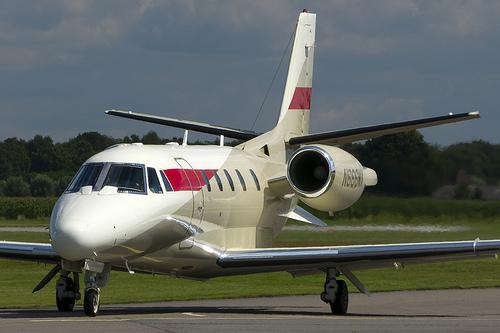Evaluate the visual quality of the image based on the provided information. The image appears to be detailed and clear, with a multitude of object elements such as clouds, grass, and various parts of the airplane being explicitly mentioned. How many total white clouds in blue sky are visible within this image? There are 9 white clouds in the blue sky. Determine the most complex reasoning task that involves both the airplane and its surroundings. Inferring the potential destination or origin of the plane based on its appearance, surroundings, and other visible objects such as signage, logos, or airport facilities. Provide a description of the airplane's tail, including its color and any additional features. The airplane's tail is red and white with a red stripe on its side and a distinct shape at the outer end. Count how many engine, landing gear (wheels), and passenger windows are there on the main airplane. There is one engine, three landing gear wheels, and two sets of passenger windows on the airplane. Craft a brief caption describing the main focus of the image. Red and white plane taking off from airport runway with clouds in blue sky overhead. Identify the main colors seen on the airplane in the picture. The plane is white, red, and tan in color. What sentiment could be conveyed through the image due to the sky's appearance? The sky's dark and gloomy appearance might evoke a sense of gloom or melancholy. Assuming this is a passenger airplane, describe its exterior features which make it suitable for carrying passengers. The exterior of the passenger airplane showcases various passenger windows, a distinct door, and the presence of one or more engines which all contribute to the airplane's ability to transport passengers. Analyze the interaction between the plane and its environment. What is it doing? The airplane is taking off from an airport runway, casting a shadow and interacting with its front and back landing gear wheels. Provide the dimensions and position of the passenger windows on the plane. X:197, Y:166, Width:66, Height:66 What interactions can be observed between the objects in this image? The plane interacts with the runway, the landing gear with the ground, and plane with its shadow. Identify the position and size of the red stripe on the tail of the plane. X:285, Y:83, Width:27, Height:27 What element of the image indicates the time of day? The position of the sun and shadows determine the time of day. Describe the shape of the plane engine. Round and dark. Identify the dimensions and position of the windows for the cockpit crew. X:70, Y:158, Width:94, Height:94 Is the general image quality high or low? The image quality is high. In terms of sentiment, how does this image make you feel? The image feels neutral, with normal everyday activity. How does the sky appear in this image? The sky appears blue with white clouds. Are there any visible numbers or letters in the image? Yes, numbers on the plane and a letter on the plane's engine. How many clouds are there in the sky? 9 white clouds are present in the blue sky. Determine if there are bushes in the image and provide their characteristics if present. Yes, there are dark green bushes present. How many wheels can be seen as part of the landing gear? Three wheels are visible - one front and two back. Identify any anomalies in this image. No significant anomalies detected in the image. Which choice below describes the location of the green grass next to the runway? A) X:245 Y:284 Width:45 Height:45 B) X:174 Y:155 Width:30 Height:30 A) X:245 Y:284 Width:45 Height:45 Given the phrase "one long shiny airplane wing", identify its position and dimensions in the image. X:208, Y:232, Width:291, Height:291 Describe the main object in this image. A red and white plane is the main object. What is the dominant color of the grass in the image? The grass is predominantly green. Identify the position and size of the plane's shadow. X:4, Y:297, Width:429, Height:429 List the colors of the airplane in the image. The plane is white, red, and tan. 